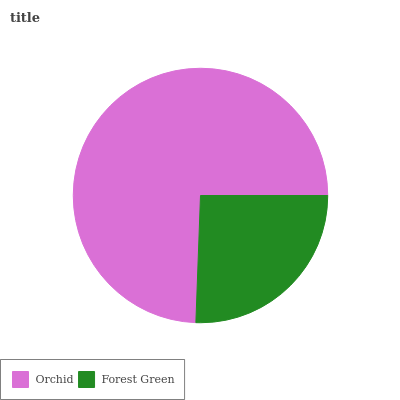Is Forest Green the minimum?
Answer yes or no. Yes. Is Orchid the maximum?
Answer yes or no. Yes. Is Forest Green the maximum?
Answer yes or no. No. Is Orchid greater than Forest Green?
Answer yes or no. Yes. Is Forest Green less than Orchid?
Answer yes or no. Yes. Is Forest Green greater than Orchid?
Answer yes or no. No. Is Orchid less than Forest Green?
Answer yes or no. No. Is Orchid the high median?
Answer yes or no. Yes. Is Forest Green the low median?
Answer yes or no. Yes. Is Forest Green the high median?
Answer yes or no. No. Is Orchid the low median?
Answer yes or no. No. 